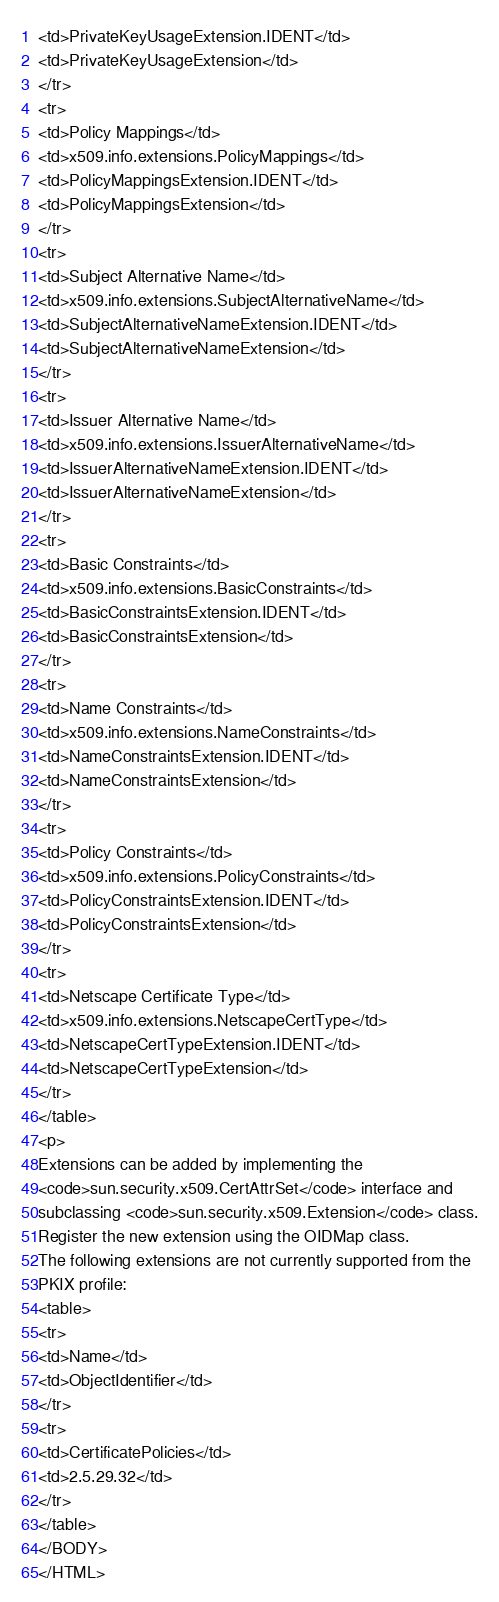<code> <loc_0><loc_0><loc_500><loc_500><_HTML_><td>PrivateKeyUsageExtension.IDENT</td>
<td>PrivateKeyUsageExtension</td>
</tr>
<tr>
<td>Policy Mappings</td>
<td>x509.info.extensions.PolicyMappings</td>
<td>PolicyMappingsExtension.IDENT</td>
<td>PolicyMappingsExtension</td>
</tr>
<tr>
<td>Subject Alternative Name</td>
<td>x509.info.extensions.SubjectAlternativeName</td>
<td>SubjectAlternativeNameExtension.IDENT</td>
<td>SubjectAlternativeNameExtension</td>
</tr>
<tr>
<td>Issuer Alternative Name</td>
<td>x509.info.extensions.IssuerAlternativeName</td>
<td>IssuerAlternativeNameExtension.IDENT</td>
<td>IssuerAlternativeNameExtension</td>
</tr>
<tr>
<td>Basic Constraints</td>
<td>x509.info.extensions.BasicConstraints</td>
<td>BasicConstraintsExtension.IDENT</td>
<td>BasicConstraintsExtension</td>
</tr>
<tr>
<td>Name Constraints</td>
<td>x509.info.extensions.NameConstraints</td>
<td>NameConstraintsExtension.IDENT</td>
<td>NameConstraintsExtension</td>
</tr>
<tr>
<td>Policy Constraints</td>
<td>x509.info.extensions.PolicyConstraints</td>
<td>PolicyConstraintsExtension.IDENT</td>
<td>PolicyConstraintsExtension</td>
</tr>
<tr>
<td>Netscape Certificate Type</td>
<td>x509.info.extensions.NetscapeCertType</td>
<td>NetscapeCertTypeExtension.IDENT</td>
<td>NetscapeCertTypeExtension</td>
</tr>
</table>
<p>
Extensions can be added by implementing the
<code>sun.security.x509.CertAttrSet</code> interface and
subclassing <code>sun.security.x509.Extension</code> class.
Register the new extension using the OIDMap class.
The following extensions are not currently supported from the
PKIX profile:
<table>
<tr>
<td>Name</td>
<td>ObjectIdentifier</td>
</tr>
<tr>
<td>CertificatePolicies</td>
<td>2.5.29.32</td>
</tr>
</table>
</BODY>
</HTML>
</code> 